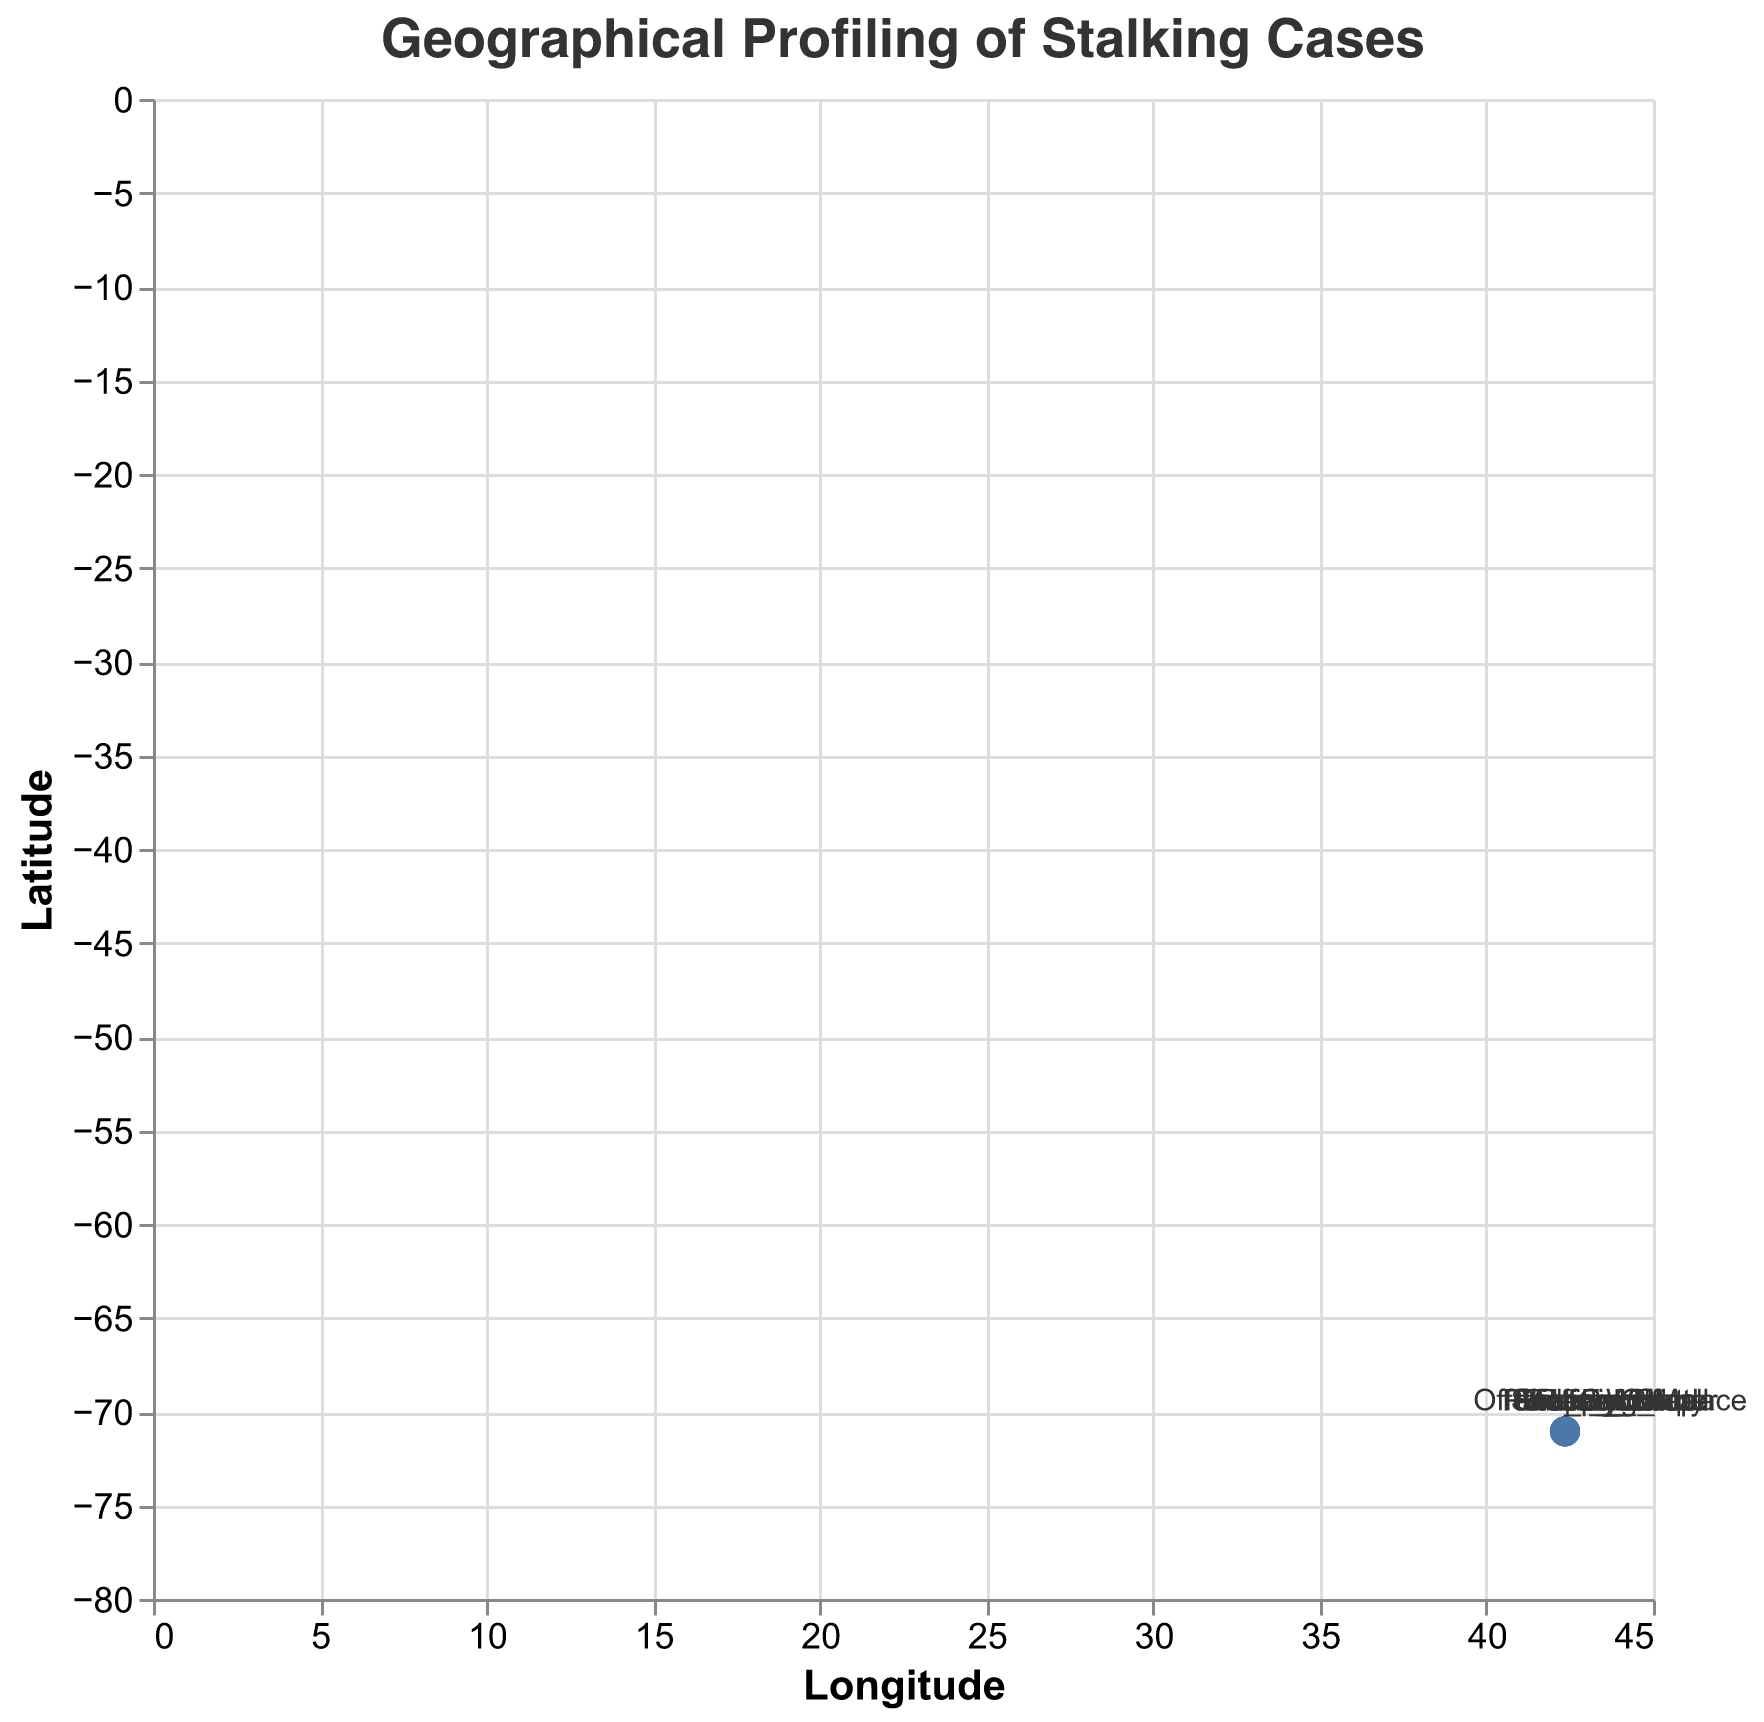What is the title of the figure? The title of the figure is displayed at the top and reads "Geographical Profiling of Stalking Cases". This information is directly readable from the figure.
Answer: Geographical Profiling of Stalking Cases How many total data points are plotted in the figure? By counting the points in the figure, you can see that there are 10 distinct data points representing different locations. Each data point corresponds to a label indicating a significant location.
Answer: 10 Which location has the largest "u" vector component? By examining the figure, the location labeled "Victim_Home" has the largest "u" vector component with a value of -0.5. This is identified by comparing the horizontal lengths of vectors.
Answer: Victim_Home What is the direction (left, right, up, or down) of the vector at the "Gym" location? The vector at the "Gym" location has "u" of 0.3 (right) and "v" of -0.4 (down). This means the vector's overall direction is to the right and downward.
Answer: Right and Down Which locations have vectors pointing upwards? To determine this, we look at locations where the "v" component is positive. The locations with vectors pointing upwards are Victim_Home, Victim_Office, Grocery_Store, and Restaurant.
Answer: Victim_Home, Victim_Office, Grocery_Store, Restaurant What is the total length of the vector at "Victim_Office"? The vector length can be calculated by the formula √(u² + v²), where u = 0.1 and v = 0.4 for "Victim_Office". Calculating this gives √(0.1² + 0.4²) = √(0.01 + 0.16) = √0.17 ≈ 0.41.
Answer: 0.41 Which location shows the smallest vector magnitude? The magnitude of a vector can be calculated and compared across locations. "Offender_Workplace" has u = 0.2 and v = -0.1. Its magnitude is √(0.2² + (-0.1)²) = √(0.04 + 0.01) = √0.05 ≈ 0.22, which is the smallest among all vectors.
Answer: Offender_Workplace Is there any trend visible in the direction of offender and victim movements? By observing the directions of the vectors, it seems that victim-related vectors tend to point upward or rightward more often, while offender-related vectors point downward or leftward. This pattern might be indicative of different behavioral patterns.
Answer: Yes What is the general direction of the movement from "Victim_Home"? The vector at "Victim_Home" has u = -0.5 and v = 0.3, indicating a general movement towards the left (negative u) and upwards (positive v).
Answer: Left and Up Are there any locations where the vector points exactly in the horizontal or vertical direction? By examining the angles, "Offender_Workplace" has vector components u = 0.2 and v = -0.1 which do not point exactly horizontal or vertical. Similarly, other vectors also do not point perfectly horizontal or vertical.
Answer: No 